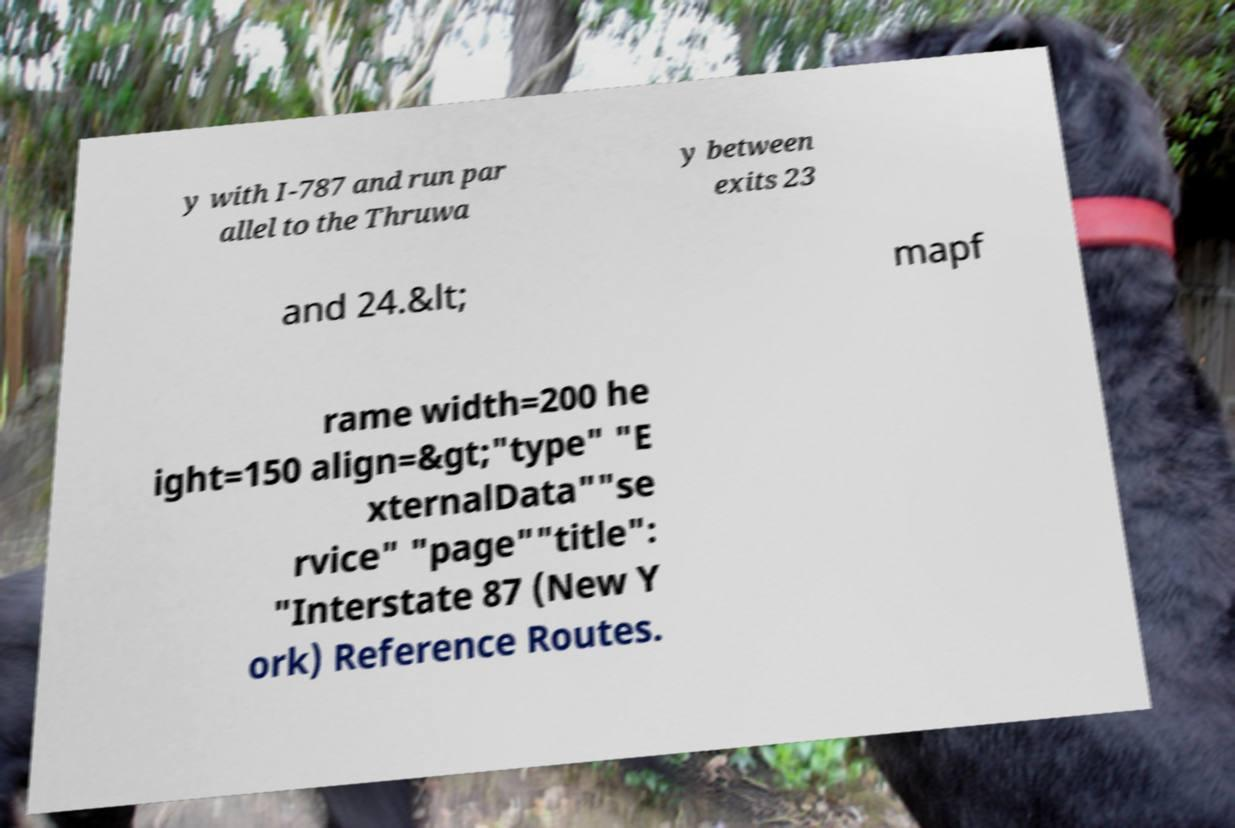I need the written content from this picture converted into text. Can you do that? y with I-787 and run par allel to the Thruwa y between exits 23 and 24.&lt; mapf rame width=200 he ight=150 align=&gt;"type" "E xternalData""se rvice" "page""title": "Interstate 87 (New Y ork) Reference Routes. 